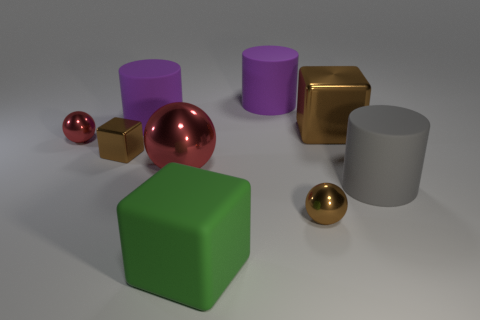The small metal thing that is the same color as the big metallic sphere is what shape?
Keep it short and to the point. Sphere. Are there any green things made of the same material as the big gray cylinder?
Keep it short and to the point. Yes. The gray matte cylinder is what size?
Offer a very short reply. Large. What number of gray things are spheres or tiny blocks?
Provide a short and direct response. 0. What number of large green rubber things have the same shape as the large brown thing?
Your answer should be very brief. 1. What number of brown metallic blocks are the same size as the green rubber object?
Your answer should be compact. 1. There is a big red object that is the same shape as the small red metallic thing; what is it made of?
Provide a succinct answer. Metal. The cube that is in front of the brown ball is what color?
Your answer should be compact. Green. Are there more cubes that are behind the small red shiny object than cyan rubber cylinders?
Make the answer very short. Yes. What is the color of the big sphere?
Keep it short and to the point. Red. 